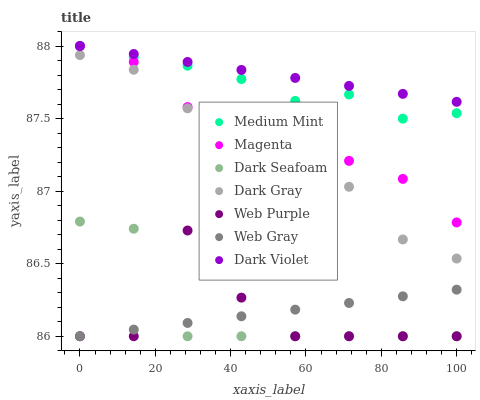Does Web Purple have the minimum area under the curve?
Answer yes or no. Yes. Does Dark Violet have the maximum area under the curve?
Answer yes or no. Yes. Does Web Gray have the minimum area under the curve?
Answer yes or no. No. Does Web Gray have the maximum area under the curve?
Answer yes or no. No. Is Web Gray the smoothest?
Answer yes or no. Yes. Is Web Purple the roughest?
Answer yes or no. Yes. Is Web Purple the smoothest?
Answer yes or no. No. Is Web Gray the roughest?
Answer yes or no. No. Does Web Gray have the lowest value?
Answer yes or no. Yes. Does Dark Violet have the lowest value?
Answer yes or no. No. Does Magenta have the highest value?
Answer yes or no. Yes. Does Web Purple have the highest value?
Answer yes or no. No. Is Web Gray less than Dark Gray?
Answer yes or no. Yes. Is Magenta greater than Dark Seafoam?
Answer yes or no. Yes. Does Medium Mint intersect Magenta?
Answer yes or no. Yes. Is Medium Mint less than Magenta?
Answer yes or no. No. Is Medium Mint greater than Magenta?
Answer yes or no. No. Does Web Gray intersect Dark Gray?
Answer yes or no. No. 